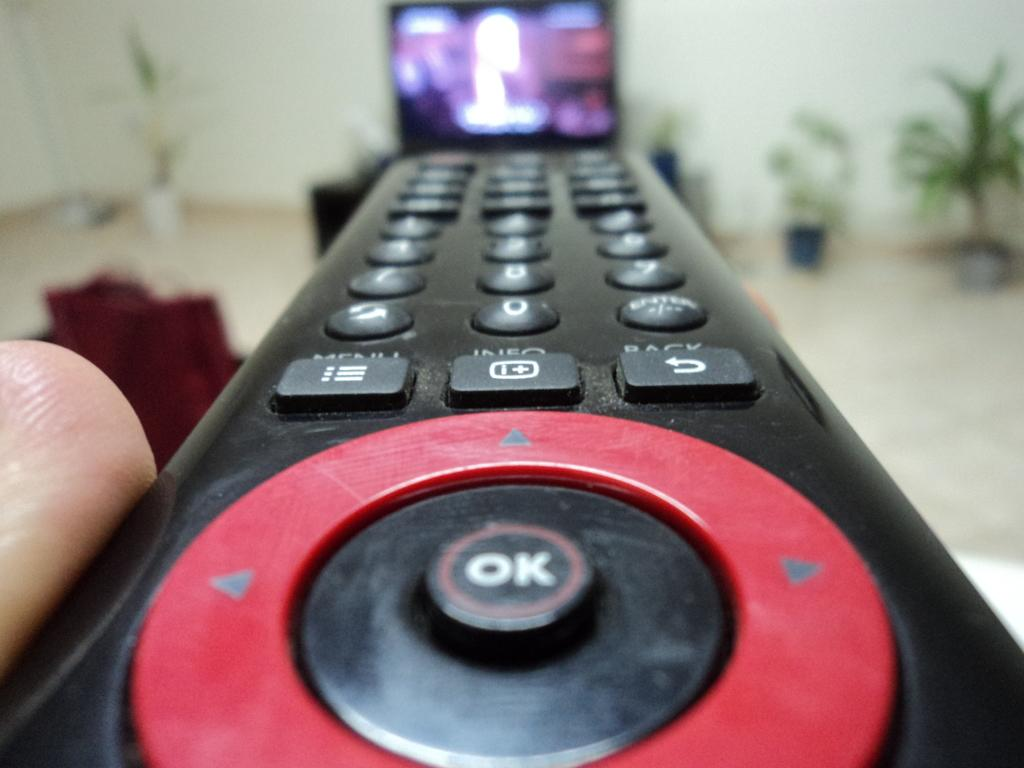<image>
Offer a succinct explanation of the picture presented. A close up image of a remote control with a red circle on it surrounding an "OK" button. 